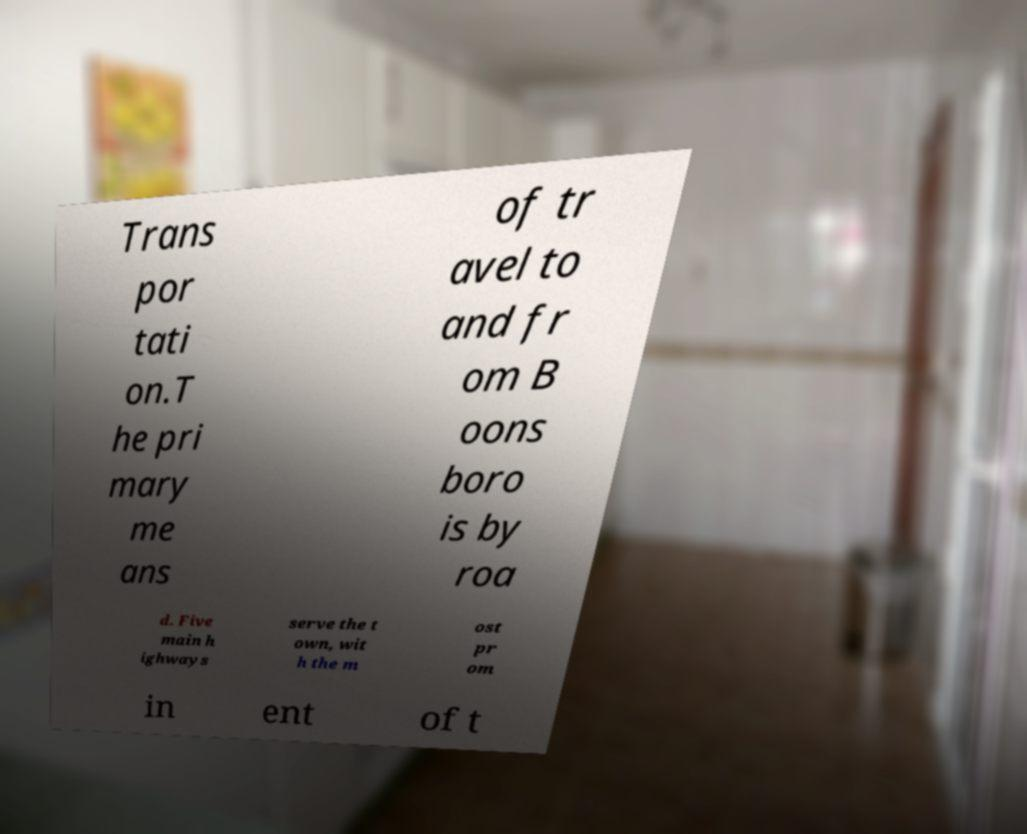Could you assist in decoding the text presented in this image and type it out clearly? Trans por tati on.T he pri mary me ans of tr avel to and fr om B oons boro is by roa d. Five main h ighways serve the t own, wit h the m ost pr om in ent of t 